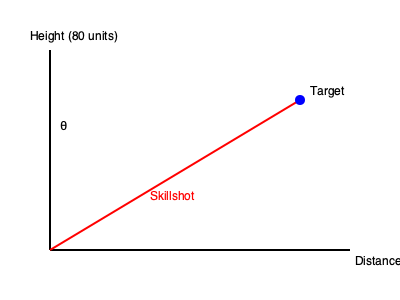As a carry player, you're practicing your skillshots with your support player. In a simplified 2D game scenario, you need to hit a target that is 250 units away horizontally and 80 units above your character's position. What is the optimal angle θ (in degrees) from the horizontal at which you should aim your skillshot to hit the target? To find the optimal angle for the skillshot, we can use trigonometry. Let's approach this step-by-step:

1) We have a right-angled triangle where:
   - The adjacent side (horizontal distance) is 250 units
   - The opposite side (vertical distance) is 80 units
   - We need to find the angle θ

2) In this scenario, we can use the tangent function:

   $$ \tan(\theta) = \frac{\text{opposite}}{\text{adjacent}} = \frac{\text{vertical distance}}{\text{horizontal distance}} $$

3) Substituting our values:

   $$ \tan(\theta) = \frac{80}{250} = 0.32 $$

4) To find θ, we need to use the inverse tangent (arctan or $\tan^{-1}$):

   $$ \theta = \tan^{-1}(0.32) $$

5) Using a calculator or programming function to compute this:

   $$ \theta \approx 17.74^\circ $$

6) Rounding to two decimal places:

   $$ \theta \approx 17.74^\circ $$

This angle will ensure that your skillshot hits the target accurately, allowing you to capitalize on the space created by your support player.
Answer: $17.74^\circ$ 